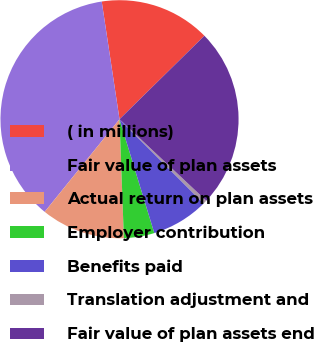<chart> <loc_0><loc_0><loc_500><loc_500><pie_chart><fcel>( in millions)<fcel>Fair value of plan assets<fcel>Actual return on plan assets<fcel>Employer contribution<fcel>Benefits paid<fcel>Translation adjustment and<fcel>Fair value of plan assets end<nl><fcel>15.02%<fcel>36.8%<fcel>11.4%<fcel>4.14%<fcel>7.77%<fcel>0.51%<fcel>24.37%<nl></chart> 